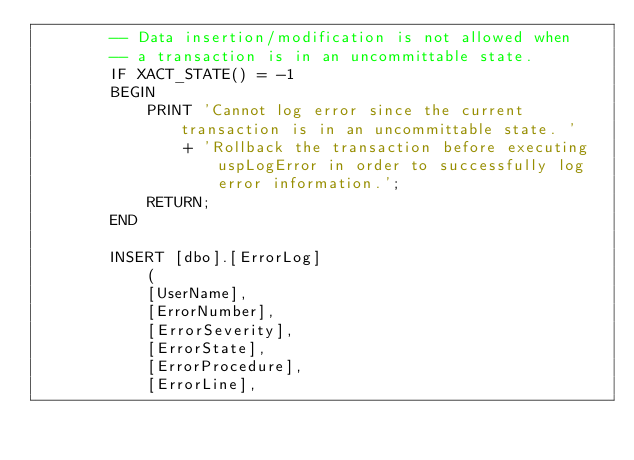Convert code to text. <code><loc_0><loc_0><loc_500><loc_500><_SQL_>        -- Data insertion/modification is not allowed when
        -- a transaction is in an uncommittable state.
        IF XACT_STATE() = -1
        BEGIN
            PRINT 'Cannot log error since the current transaction is in an uncommittable state. '
                + 'Rollback the transaction before executing uspLogError in order to successfully log error information.';
            RETURN;
        END

        INSERT [dbo].[ErrorLog]
            (
            [UserName],
            [ErrorNumber],
            [ErrorSeverity],
            [ErrorState],
            [ErrorProcedure],
            [ErrorLine],</code> 